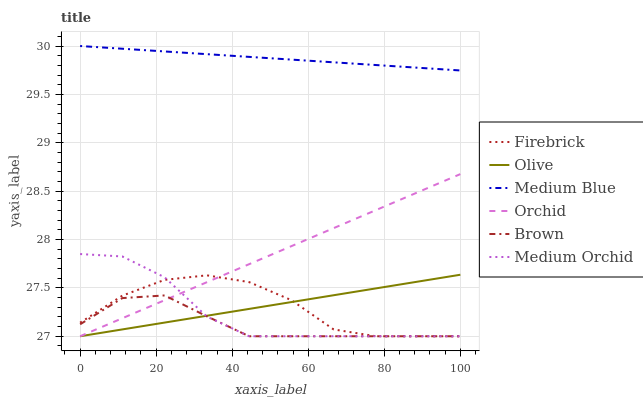Does Brown have the minimum area under the curve?
Answer yes or no. Yes. Does Medium Blue have the maximum area under the curve?
Answer yes or no. Yes. Does Firebrick have the minimum area under the curve?
Answer yes or no. No. Does Firebrick have the maximum area under the curve?
Answer yes or no. No. Is Olive the smoothest?
Answer yes or no. Yes. Is Firebrick the roughest?
Answer yes or no. Yes. Is Medium Orchid the smoothest?
Answer yes or no. No. Is Medium Orchid the roughest?
Answer yes or no. No. Does Brown have the lowest value?
Answer yes or no. Yes. Does Medium Blue have the lowest value?
Answer yes or no. No. Does Medium Blue have the highest value?
Answer yes or no. Yes. Does Firebrick have the highest value?
Answer yes or no. No. Is Medium Orchid less than Medium Blue?
Answer yes or no. Yes. Is Medium Blue greater than Firebrick?
Answer yes or no. Yes. Does Olive intersect Brown?
Answer yes or no. Yes. Is Olive less than Brown?
Answer yes or no. No. Is Olive greater than Brown?
Answer yes or no. No. Does Medium Orchid intersect Medium Blue?
Answer yes or no. No. 